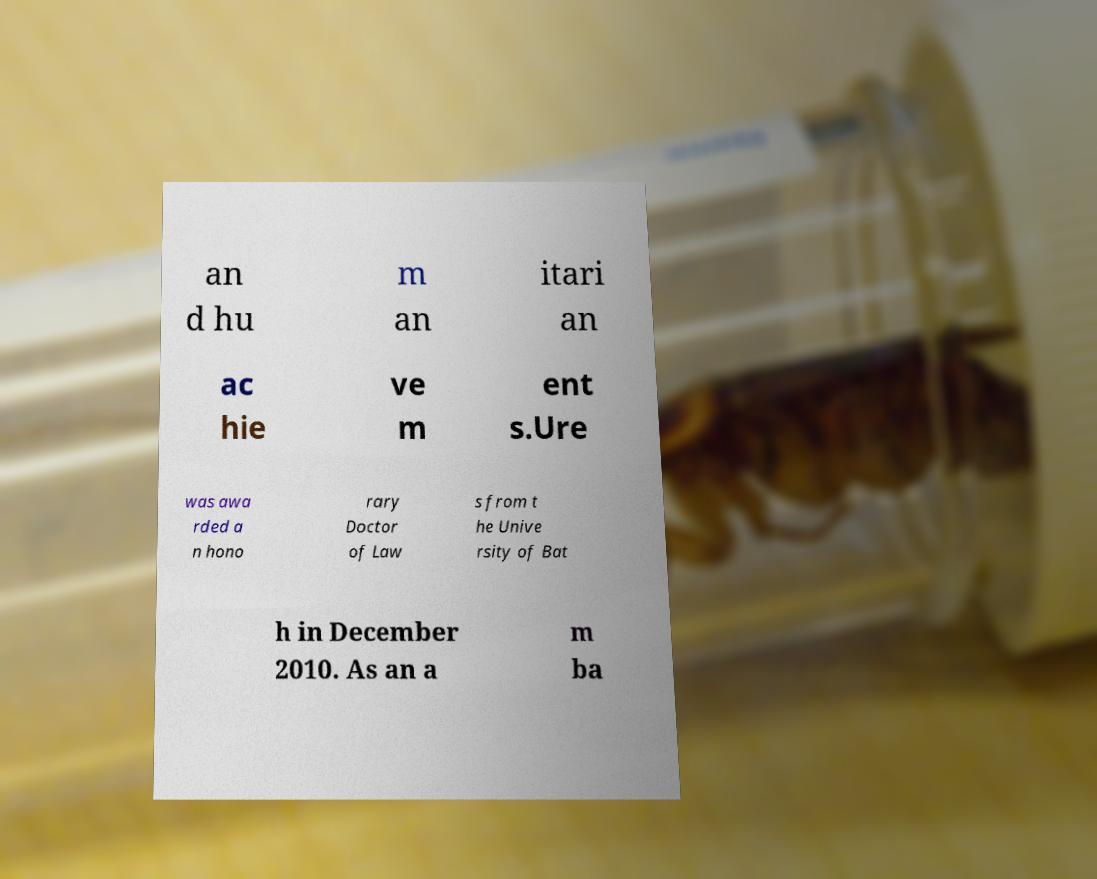Please read and relay the text visible in this image. What does it say? an d hu m an itari an ac hie ve m ent s.Ure was awa rded a n hono rary Doctor of Law s from t he Unive rsity of Bat h in December 2010. As an a m ba 